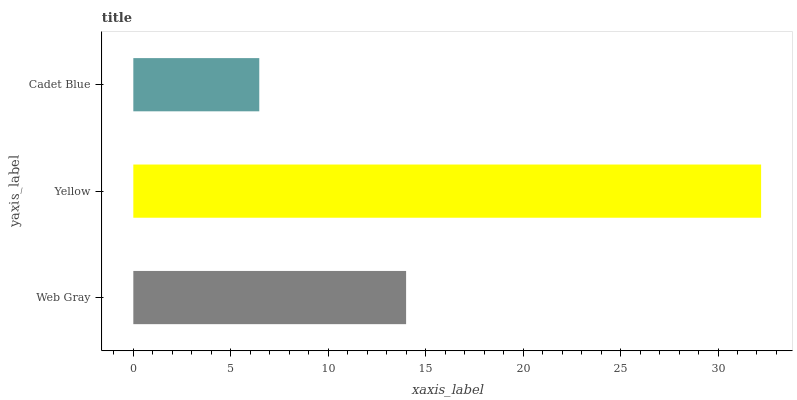Is Cadet Blue the minimum?
Answer yes or no. Yes. Is Yellow the maximum?
Answer yes or no. Yes. Is Yellow the minimum?
Answer yes or no. No. Is Cadet Blue the maximum?
Answer yes or no. No. Is Yellow greater than Cadet Blue?
Answer yes or no. Yes. Is Cadet Blue less than Yellow?
Answer yes or no. Yes. Is Cadet Blue greater than Yellow?
Answer yes or no. No. Is Yellow less than Cadet Blue?
Answer yes or no. No. Is Web Gray the high median?
Answer yes or no. Yes. Is Web Gray the low median?
Answer yes or no. Yes. Is Cadet Blue the high median?
Answer yes or no. No. Is Cadet Blue the low median?
Answer yes or no. No. 